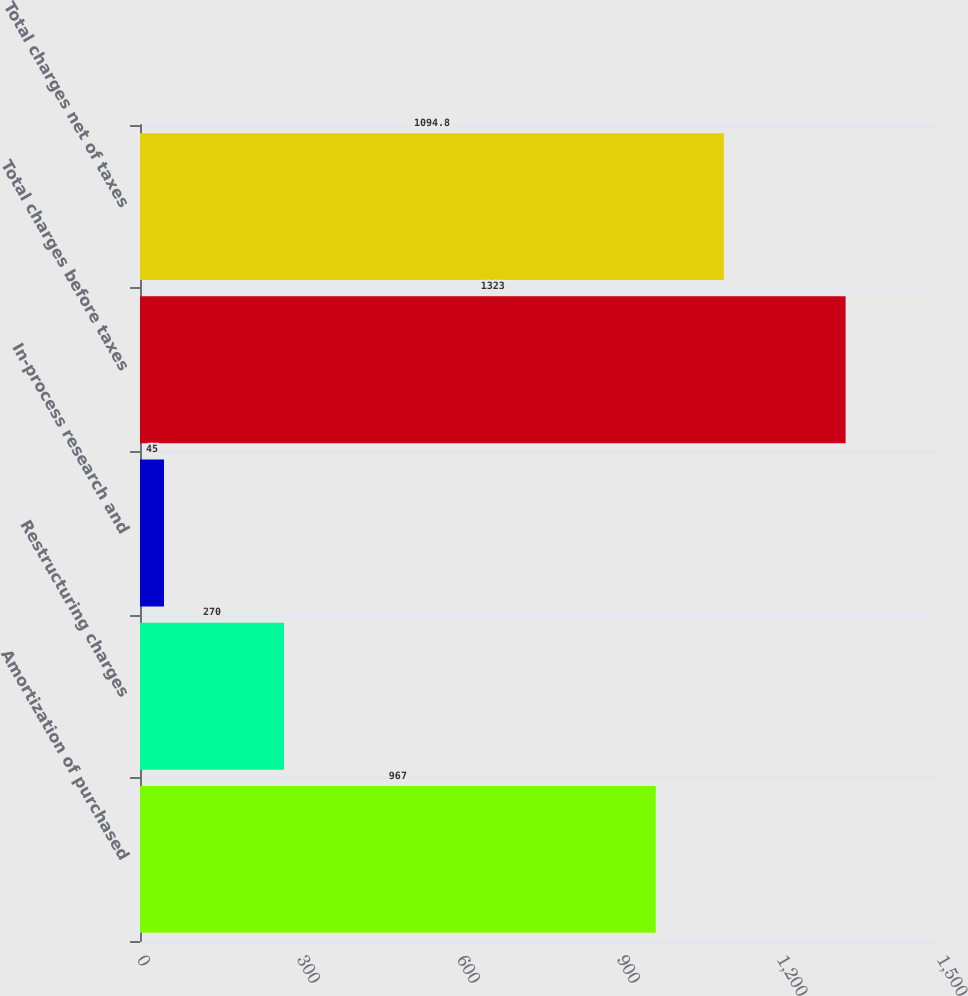Convert chart to OTSL. <chart><loc_0><loc_0><loc_500><loc_500><bar_chart><fcel>Amortization of purchased<fcel>Restructuring charges<fcel>In-process research and<fcel>Total charges before taxes<fcel>Total charges net of taxes<nl><fcel>967<fcel>270<fcel>45<fcel>1323<fcel>1094.8<nl></chart> 